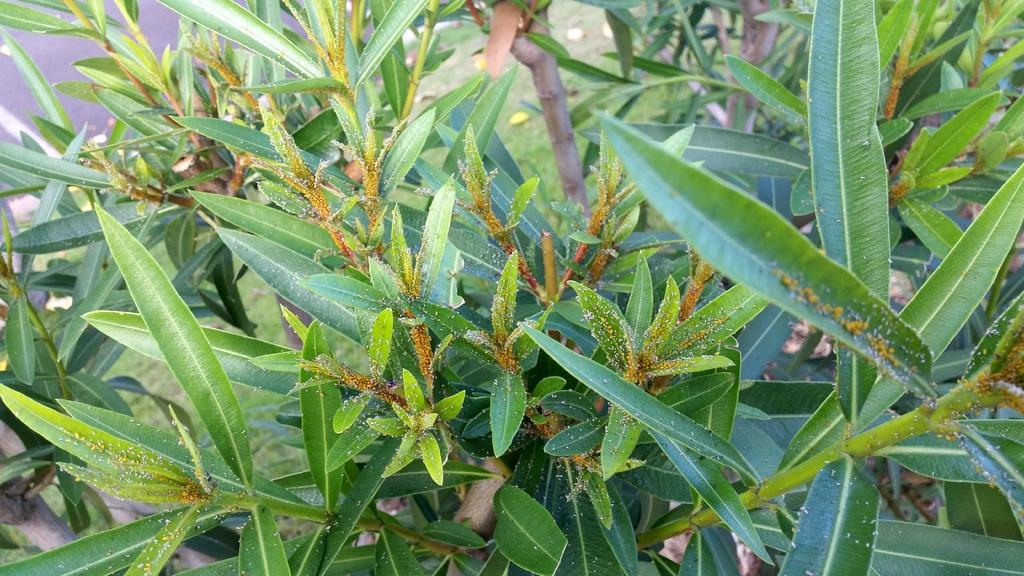What type of vegetation can be seen in the image? There are trees in the image. What type of steel is visible in the image? There is no steel present in the image; it only features trees. 